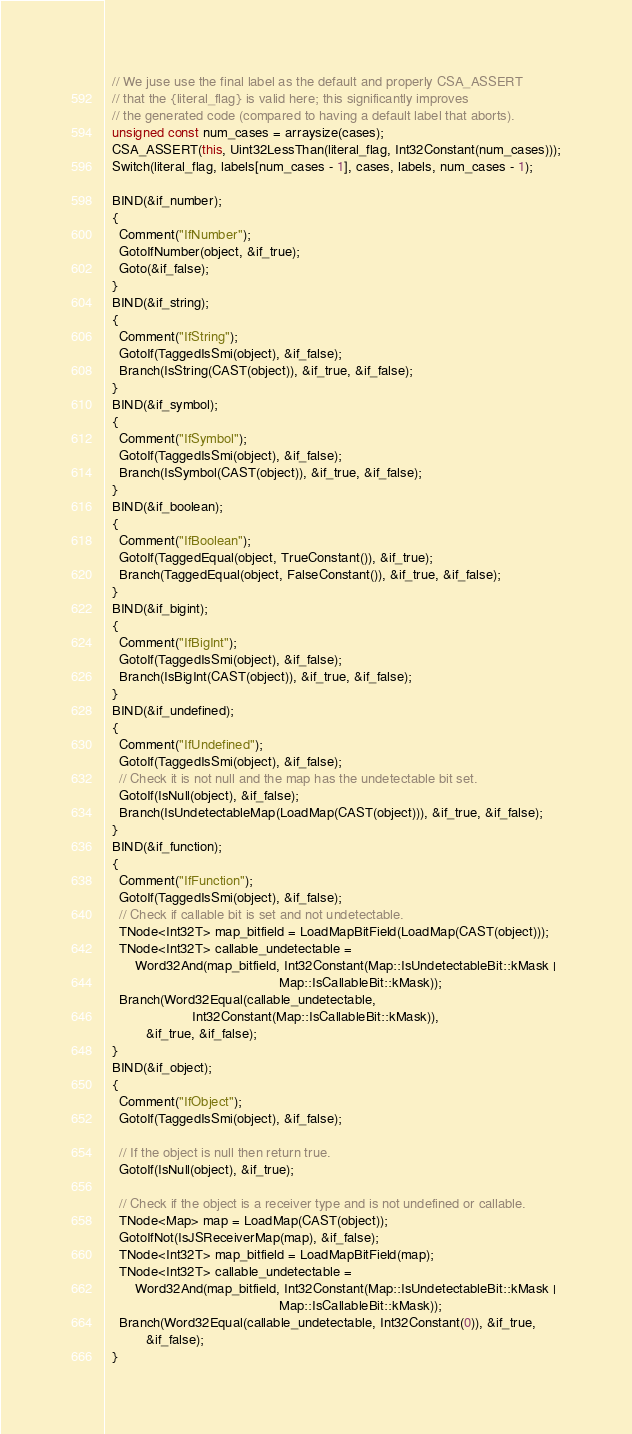Convert code to text. <code><loc_0><loc_0><loc_500><loc_500><_C++_>  // We juse use the final label as the default and properly CSA_ASSERT
  // that the {literal_flag} is valid here; this significantly improves
  // the generated code (compared to having a default label that aborts).
  unsigned const num_cases = arraysize(cases);
  CSA_ASSERT(this, Uint32LessThan(literal_flag, Int32Constant(num_cases)));
  Switch(literal_flag, labels[num_cases - 1], cases, labels, num_cases - 1);

  BIND(&if_number);
  {
    Comment("IfNumber");
    GotoIfNumber(object, &if_true);
    Goto(&if_false);
  }
  BIND(&if_string);
  {
    Comment("IfString");
    GotoIf(TaggedIsSmi(object), &if_false);
    Branch(IsString(CAST(object)), &if_true, &if_false);
  }
  BIND(&if_symbol);
  {
    Comment("IfSymbol");
    GotoIf(TaggedIsSmi(object), &if_false);
    Branch(IsSymbol(CAST(object)), &if_true, &if_false);
  }
  BIND(&if_boolean);
  {
    Comment("IfBoolean");
    GotoIf(TaggedEqual(object, TrueConstant()), &if_true);
    Branch(TaggedEqual(object, FalseConstant()), &if_true, &if_false);
  }
  BIND(&if_bigint);
  {
    Comment("IfBigInt");
    GotoIf(TaggedIsSmi(object), &if_false);
    Branch(IsBigInt(CAST(object)), &if_true, &if_false);
  }
  BIND(&if_undefined);
  {
    Comment("IfUndefined");
    GotoIf(TaggedIsSmi(object), &if_false);
    // Check it is not null and the map has the undetectable bit set.
    GotoIf(IsNull(object), &if_false);
    Branch(IsUndetectableMap(LoadMap(CAST(object))), &if_true, &if_false);
  }
  BIND(&if_function);
  {
    Comment("IfFunction");
    GotoIf(TaggedIsSmi(object), &if_false);
    // Check if callable bit is set and not undetectable.
    TNode<Int32T> map_bitfield = LoadMapBitField(LoadMap(CAST(object)));
    TNode<Int32T> callable_undetectable =
        Word32And(map_bitfield, Int32Constant(Map::IsUndetectableBit::kMask |
                                              Map::IsCallableBit::kMask));
    Branch(Word32Equal(callable_undetectable,
                       Int32Constant(Map::IsCallableBit::kMask)),
           &if_true, &if_false);
  }
  BIND(&if_object);
  {
    Comment("IfObject");
    GotoIf(TaggedIsSmi(object), &if_false);

    // If the object is null then return true.
    GotoIf(IsNull(object), &if_true);

    // Check if the object is a receiver type and is not undefined or callable.
    TNode<Map> map = LoadMap(CAST(object));
    GotoIfNot(IsJSReceiverMap(map), &if_false);
    TNode<Int32T> map_bitfield = LoadMapBitField(map);
    TNode<Int32T> callable_undetectable =
        Word32And(map_bitfield, Int32Constant(Map::IsUndetectableBit::kMask |
                                              Map::IsCallableBit::kMask));
    Branch(Word32Equal(callable_undetectable, Int32Constant(0)), &if_true,
           &if_false);
  }</code> 